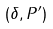Convert formula to latex. <formula><loc_0><loc_0><loc_500><loc_500>( \delta , P ^ { \prime } )</formula> 